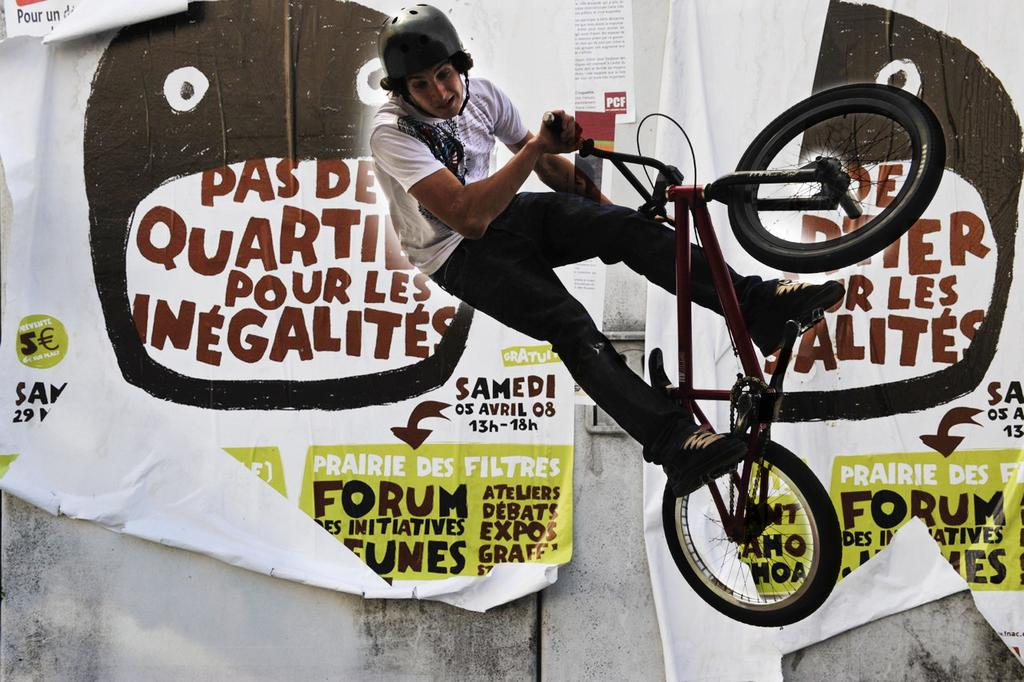What is the person in the image doing? The person is riding a bicycle in the image. What safety precaution is the person taking while riding the bicycle? The person is wearing a helmet. What can be seen in the background of the image? There is a paper in the background of the image. Can you describe the content of the paper? There is text written on the paper. What type of art can be seen on the person's helmet in the image? There is no art visible on the person's helmet in the image. What health benefits does the person gain from riding the bicycle in the image? The image does not provide information about the person's health or any potential health benefits from riding the bicycle. 